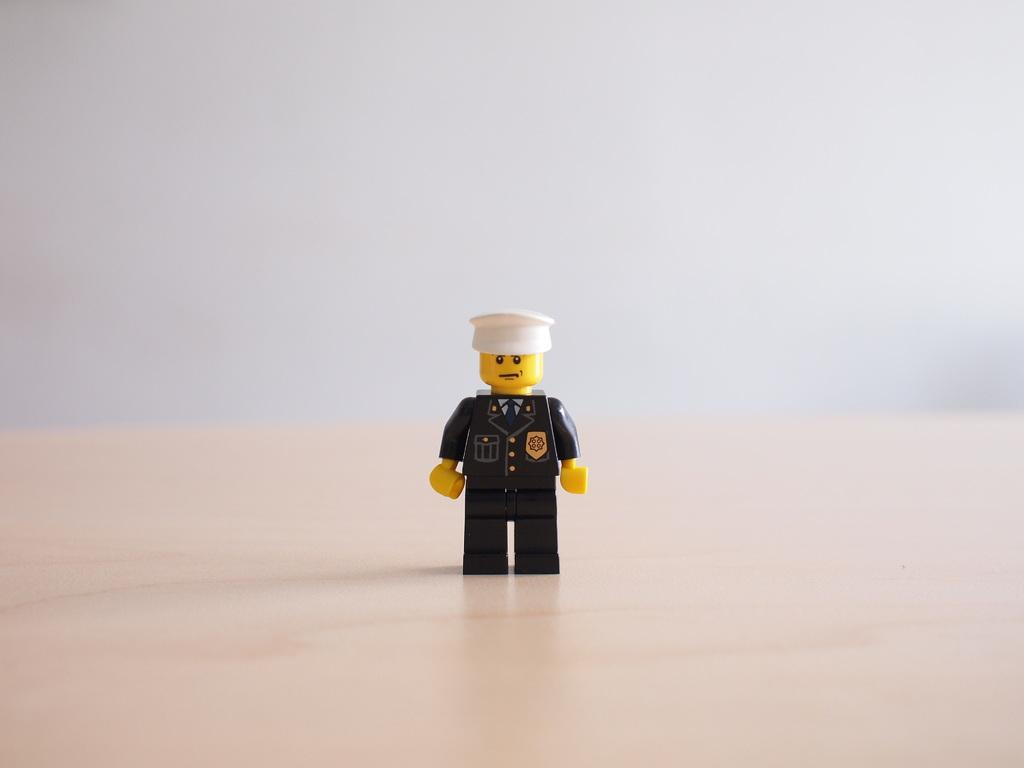What is the main subject of the picture? The main subject of the picture is a toy man. What color is the uniform worn by the toy man? The toy man is wearing a blue uniform. What other colors can be seen on the toy man? The toy man has yellow hands and face. What type of headwear is the toy man wearing? The toy man is wearing a white cap. How many sheep are visible in the picture? There are no sheep present in the picture; the main subject is a toy man. 